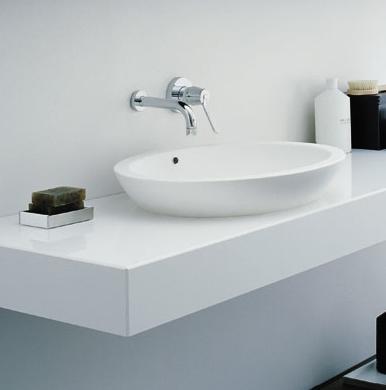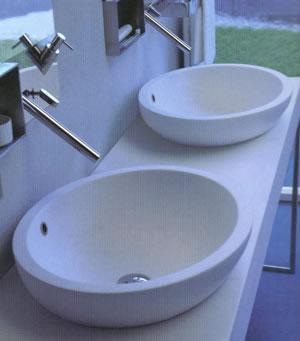The first image is the image on the left, the second image is the image on the right. Analyze the images presented: Is the assertion "There are four white folded towels in a shelf under a sink." valid? Answer yes or no. No. The first image is the image on the left, the second image is the image on the right. Examine the images to the left and right. Is the description "There are two basins on the counter in the image on the right." accurate? Answer yes or no. Yes. 